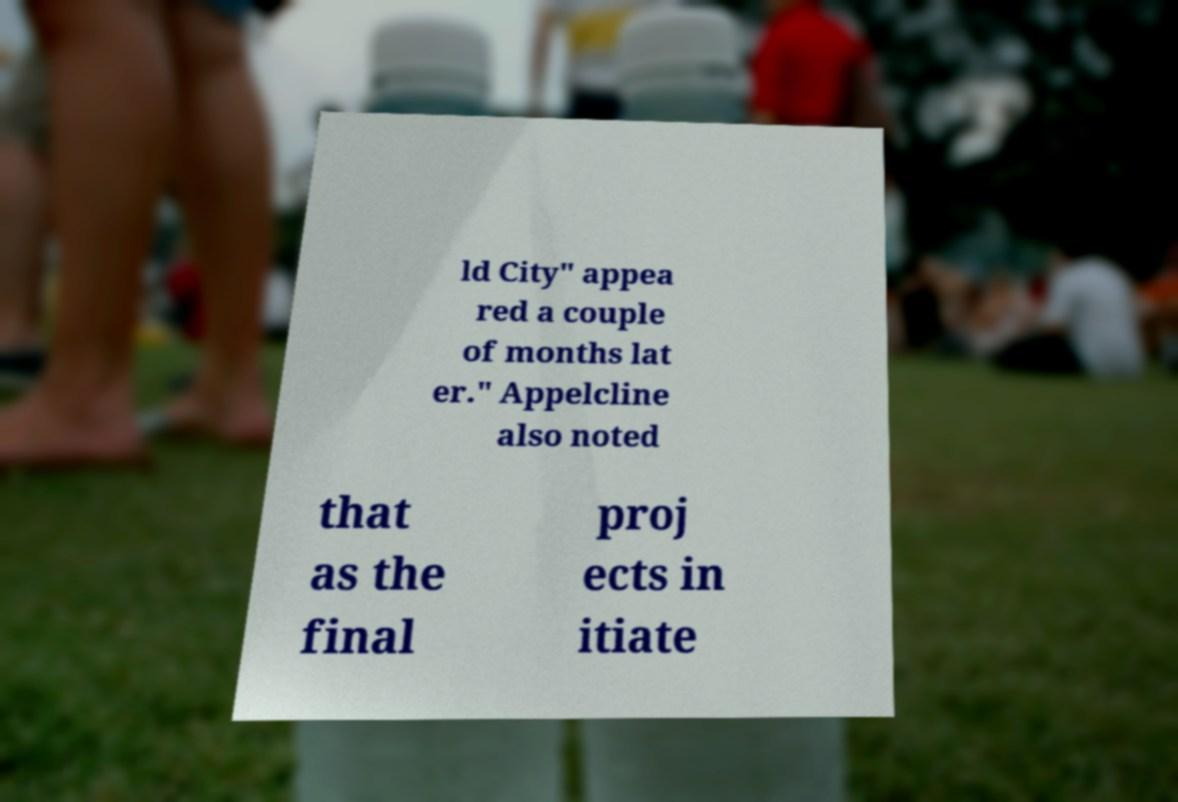Can you read and provide the text displayed in the image?This photo seems to have some interesting text. Can you extract and type it out for me? ld City" appea red a couple of months lat er." Appelcline also noted that as the final proj ects in itiate 